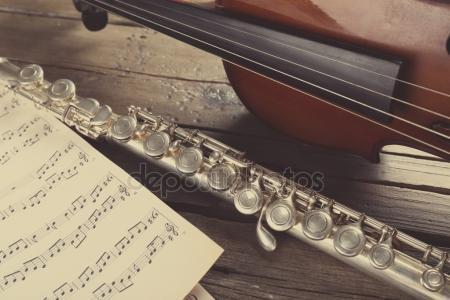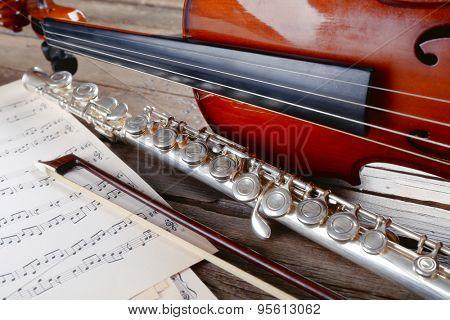The first image is the image on the left, the second image is the image on the right. Assess this claim about the two images: "The left image contains three humans on a stage playing musical instruments.". Correct or not? Answer yes or no. No. The first image is the image on the left, the second image is the image on the right. Examine the images to the left and right. Is the description "The left image shows a trio of musicians on a stage, with the person on the far left standing playing a wind instrument and the person on the far right sitting playing a string instrument." accurate? Answer yes or no. No. 